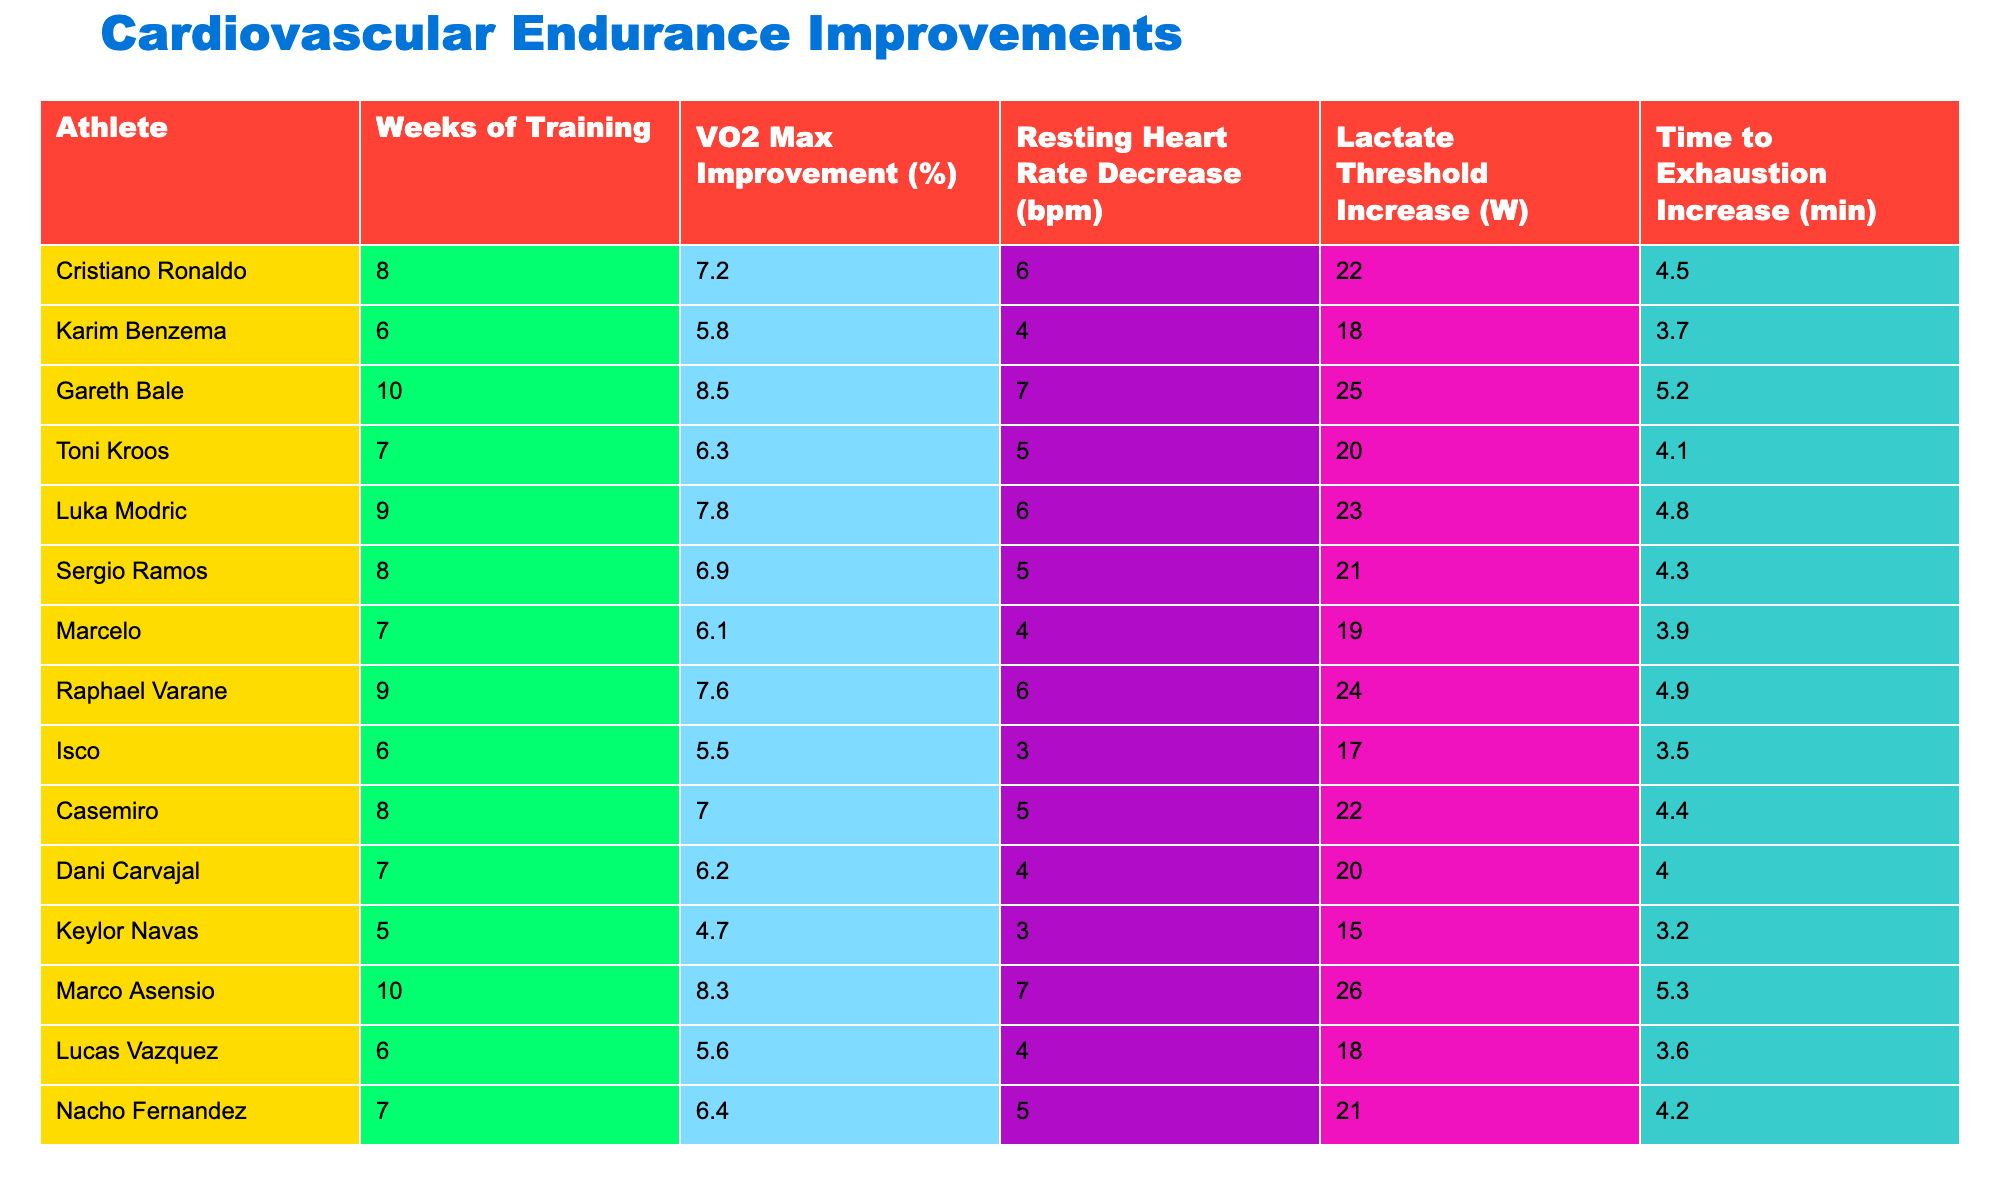What is the VO2 Max improvement for Gareth Bale? The table shows Gareth Bale's VO2 Max improvement is listed as 8.5%.
Answer: 8.5% Which athlete had the highest resting heart rate decrease, and what was the value? The table indicates Gareth Bale had the highest resting heart rate decrease at 7 bpm.
Answer: 7 bpm How many weeks of training did Marco Asensio complete? According to the table, Marco Asensio trained for 10 weeks.
Answer: 10 weeks What was the average VO2 Max improvement among all athletes? To find the average, sum all VO2 Max improvements (7.2 + 5.8 + 8.5 + 6.3 + 7.8 + 6.9 + 6.1 + 7.6 + 5.5 + 7.0 + 6.2 + 4.7 + 8.3 + 5.6 + 6.4 = 6.79), and divide by 15 (the number of athletes). The average is approximately 6.79%.
Answer: 6.79% Is there an athlete with a resting heart rate decrease of 4 bpm? Checking the table reveals that both Karim Benzema and Dani Carvajal have resting heart rate decreases of 4 bpm, confirming that the statement is true.
Answer: Yes What is the total increase in lactate threshold from the athletes who trained for more than 8 weeks? The athletes who trained for more than 8 weeks are Gareth Bale (25), Luka Modric (23), Marco Asensio (26), and Raphael Varane (24). Adding these (25 + 23 + 26 + 24 = 98) provides a total increase of 98 W.
Answer: 98 W Find the athlete who had the lowest increase in time to exhaustion. Inspecting the table, Isco had the lowest increase in time to exhaustion, which is 3.5 minutes.
Answer: 3.5 minutes What is the median value of the VO2 Max improvements from the athletes? First, arrange the VO2 Max improvements in ascending order: 4.7, 5.5, 5.6, 5.8, 6.1, 6.2, 6.3, 6.4, 6.9, 7.0, 7.2, 7.6, 7.8, 8.3, 8.5. The median is the middle value in the ordered list, which is the 8th value (6.4).
Answer: 6.4% Which athlete improved their lactate threshold by 22 W and what was their resting heart rate change? The athlete that improved their lactate threshold by 22 W is Cristiano Ronaldo, whose resting heart rate decreased by 6 bpm.
Answer: Cristiano Ronaldo, 6 bpm What percentage of athletes improved their VO2 Max by more than 7%? Looking at the table, the athletes who improved their VO2 Max by more than 7% are Gareth Bale, Luka Modric, Marco Asensio, and Raphael Varane—4 out of 15 athletes. Therefore, the percentage is (4/15)*100 = 26.67%.
Answer: 26.67% What is the difference in lactate threshold increase between the best and the worst performing athlete? The highest lactate threshold increase is from Marco Asensio (26 W), and the lowest is from Isco (17 W), giving a difference of 26 - 17 = 9 W.
Answer: 9 W 